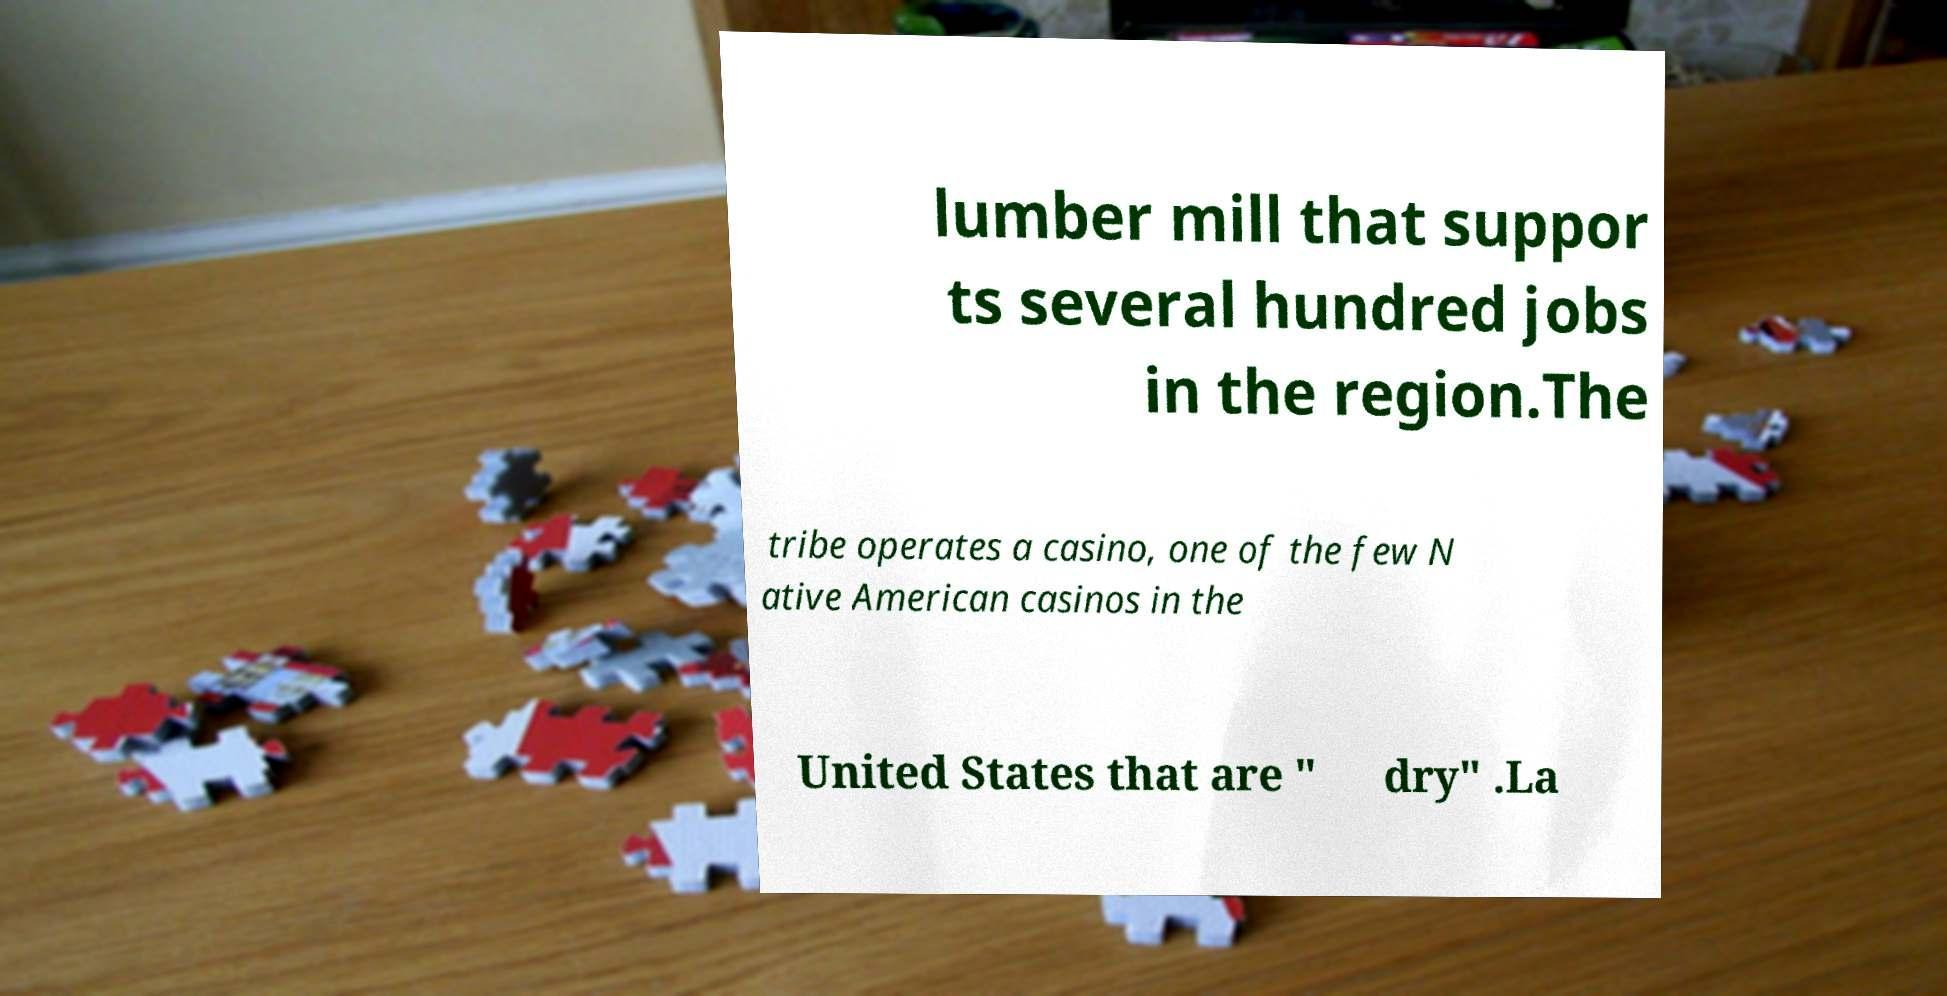Could you assist in decoding the text presented in this image and type it out clearly? lumber mill that suppor ts several hundred jobs in the region.The tribe operates a casino, one of the few N ative American casinos in the United States that are " dry" .La 